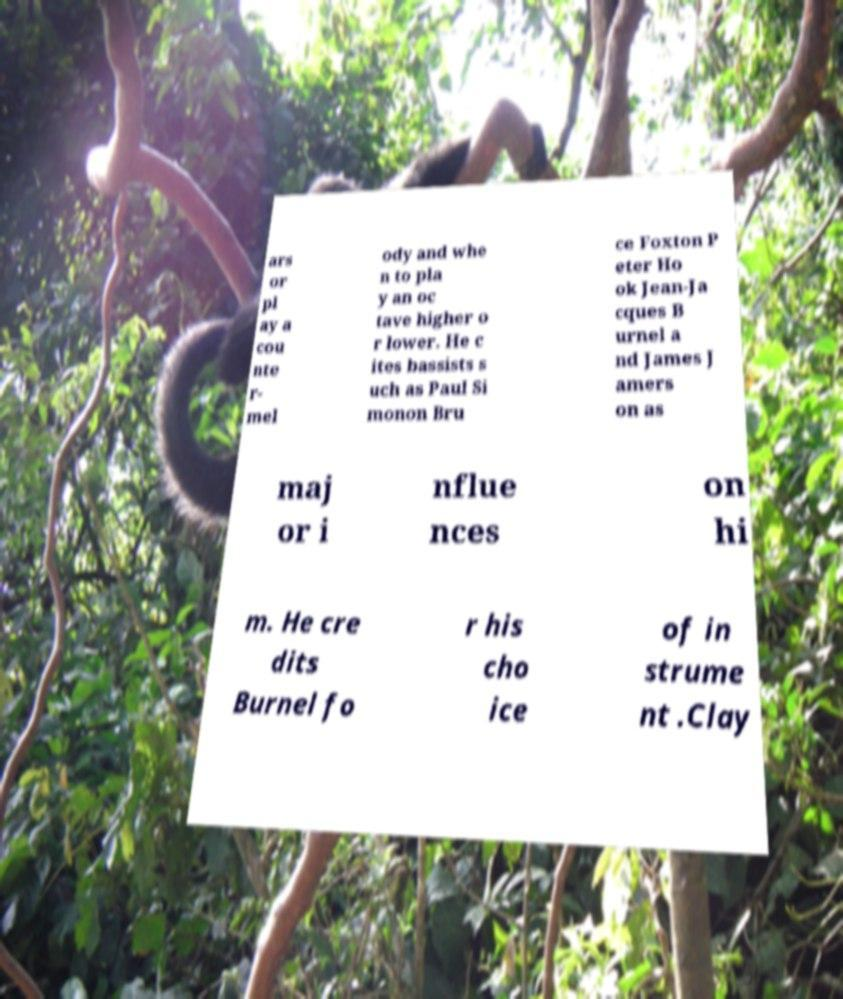Could you assist in decoding the text presented in this image and type it out clearly? ars or pl ay a cou nte r- mel ody and whe n to pla y an oc tave higher o r lower. He c ites bassists s uch as Paul Si monon Bru ce Foxton P eter Ho ok Jean-Ja cques B urnel a nd James J amers on as maj or i nflue nces on hi m. He cre dits Burnel fo r his cho ice of in strume nt .Clay 